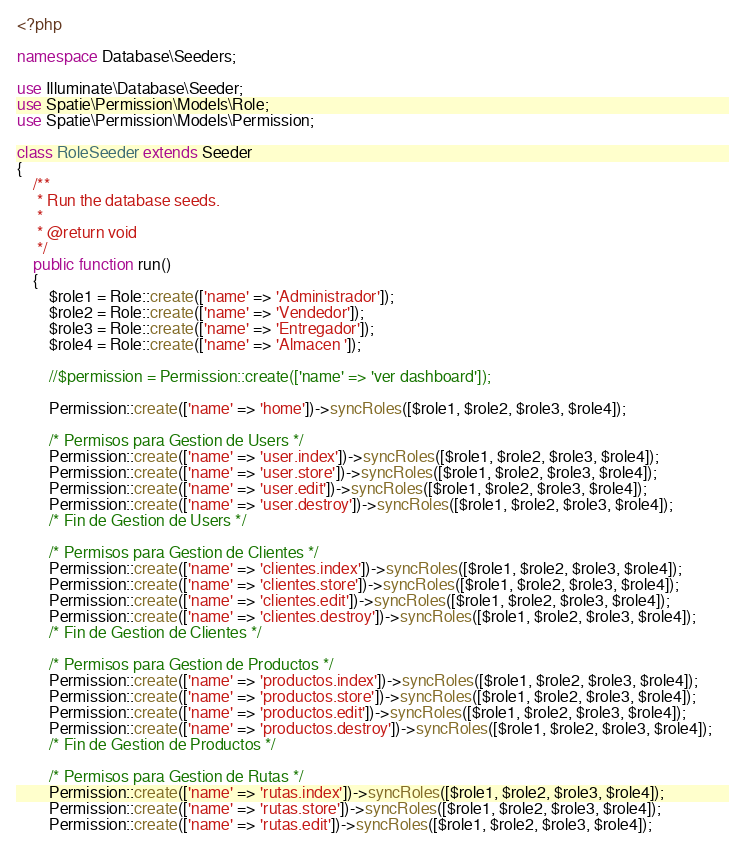Convert code to text. <code><loc_0><loc_0><loc_500><loc_500><_PHP_><?php

namespace Database\Seeders;

use Illuminate\Database\Seeder;
use Spatie\Permission\Models\Role;
use Spatie\Permission\Models\Permission;

class RoleSeeder extends Seeder
{
    /**
     * Run the database seeds.
     *
     * @return void
     */
    public function run()
    {
        $role1 = Role::create(['name' => 'Administrador']);
        $role2 = Role::create(['name' => 'Vendedor']);
        $role3 = Role::create(['name' => 'Entregador']);
        $role4 = Role::create(['name' => 'Almacen ']);

        //$permission = Permission::create(['name' => 'ver dashboard']);

        Permission::create(['name' => 'home'])->syncRoles([$role1, $role2, $role3, $role4]);

        /* Permisos para Gestion de Users */
        Permission::create(['name' => 'user.index'])->syncRoles([$role1, $role2, $role3, $role4]);
        Permission::create(['name' => 'user.store'])->syncRoles([$role1, $role2, $role3, $role4]);
        Permission::create(['name' => 'user.edit'])->syncRoles([$role1, $role2, $role3, $role4]);
        Permission::create(['name' => 'user.destroy'])->syncRoles([$role1, $role2, $role3, $role4]);
        /* Fin de Gestion de Users */

        /* Permisos para Gestion de Clientes */
        Permission::create(['name' => 'clientes.index'])->syncRoles([$role1, $role2, $role3, $role4]);
        Permission::create(['name' => 'clientes.store'])->syncRoles([$role1, $role2, $role3, $role4]);
        Permission::create(['name' => 'clientes.edit'])->syncRoles([$role1, $role2, $role3, $role4]);
        Permission::create(['name' => 'clientes.destroy'])->syncRoles([$role1, $role2, $role3, $role4]);
        /* Fin de Gestion de Clientes */

        /* Permisos para Gestion de Productos */
        Permission::create(['name' => 'productos.index'])->syncRoles([$role1, $role2, $role3, $role4]);
        Permission::create(['name' => 'productos.store'])->syncRoles([$role1, $role2, $role3, $role4]);
        Permission::create(['name' => 'productos.edit'])->syncRoles([$role1, $role2, $role3, $role4]);
        Permission::create(['name' => 'productos.destroy'])->syncRoles([$role1, $role2, $role3, $role4]);
        /* Fin de Gestion de Productos */

        /* Permisos para Gestion de Rutas */
        Permission::create(['name' => 'rutas.index'])->syncRoles([$role1, $role2, $role3, $role4]);
        Permission::create(['name' => 'rutas.store'])->syncRoles([$role1, $role2, $role3, $role4]);
        Permission::create(['name' => 'rutas.edit'])->syncRoles([$role1, $role2, $role3, $role4]);</code> 